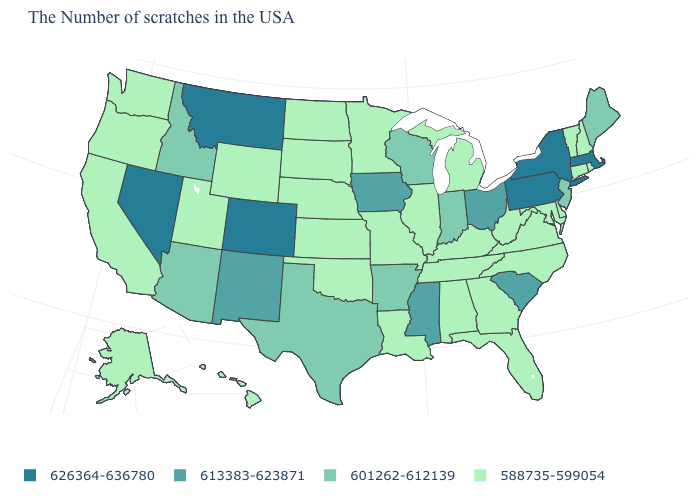Does the map have missing data?
Write a very short answer. No. What is the value of Alaska?
Give a very brief answer. 588735-599054. What is the value of Pennsylvania?
Concise answer only. 626364-636780. What is the value of Georgia?
Short answer required. 588735-599054. What is the value of Alaska?
Keep it brief. 588735-599054. Name the states that have a value in the range 601262-612139?
Give a very brief answer. Maine, New Jersey, Indiana, Wisconsin, Arkansas, Texas, Arizona, Idaho. Name the states that have a value in the range 601262-612139?
Quick response, please. Maine, New Jersey, Indiana, Wisconsin, Arkansas, Texas, Arizona, Idaho. Name the states that have a value in the range 613383-623871?
Give a very brief answer. South Carolina, Ohio, Mississippi, Iowa, New Mexico. Does Iowa have the highest value in the USA?
Be succinct. No. Does Arizona have the lowest value in the West?
Give a very brief answer. No. How many symbols are there in the legend?
Keep it brief. 4. What is the value of Illinois?
Give a very brief answer. 588735-599054. Among the states that border Indiana , which have the lowest value?
Be succinct. Michigan, Kentucky, Illinois. Which states have the lowest value in the MidWest?
Keep it brief. Michigan, Illinois, Missouri, Minnesota, Kansas, Nebraska, South Dakota, North Dakota. Does the first symbol in the legend represent the smallest category?
Short answer required. No. 